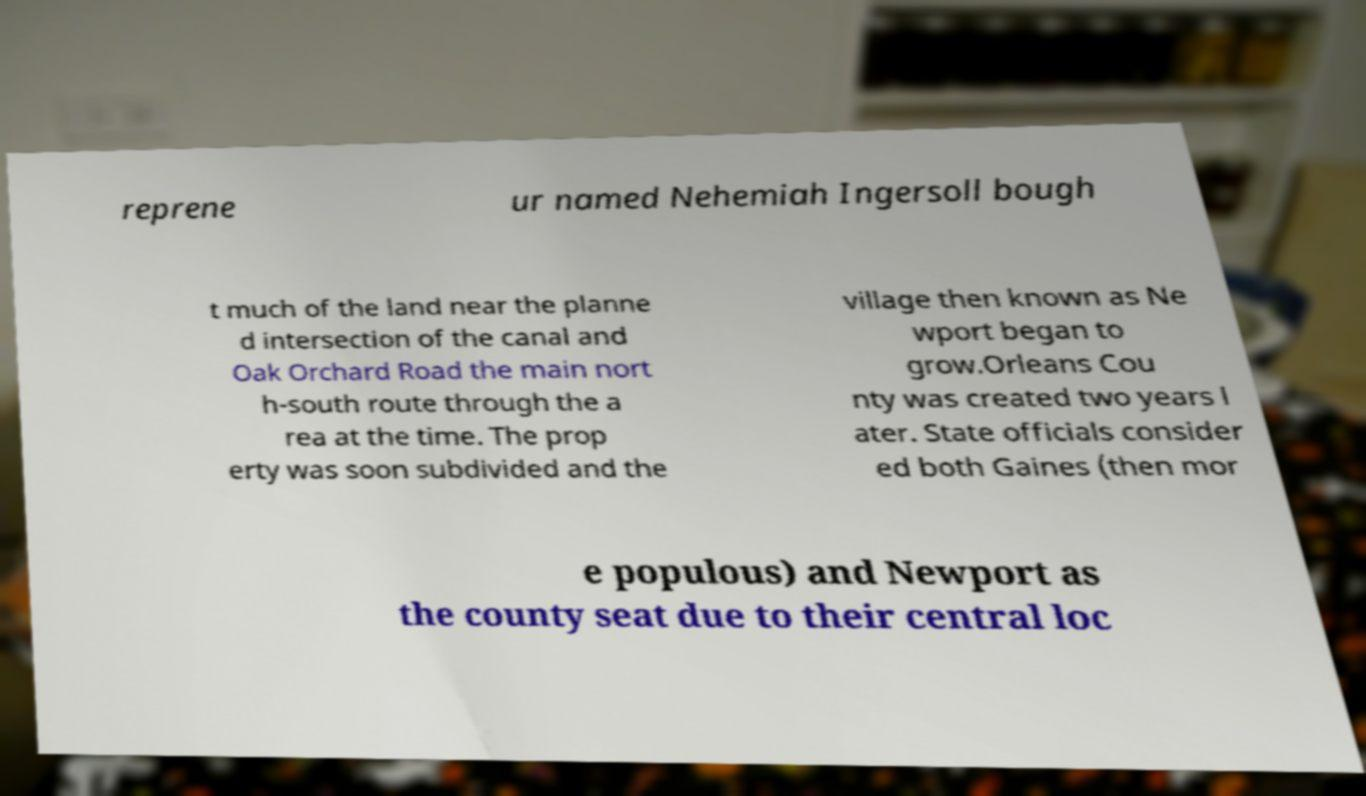For documentation purposes, I need the text within this image transcribed. Could you provide that? reprene ur named Nehemiah Ingersoll bough t much of the land near the planne d intersection of the canal and Oak Orchard Road the main nort h-south route through the a rea at the time. The prop erty was soon subdivided and the village then known as Ne wport began to grow.Orleans Cou nty was created two years l ater. State officials consider ed both Gaines (then mor e populous) and Newport as the county seat due to their central loc 